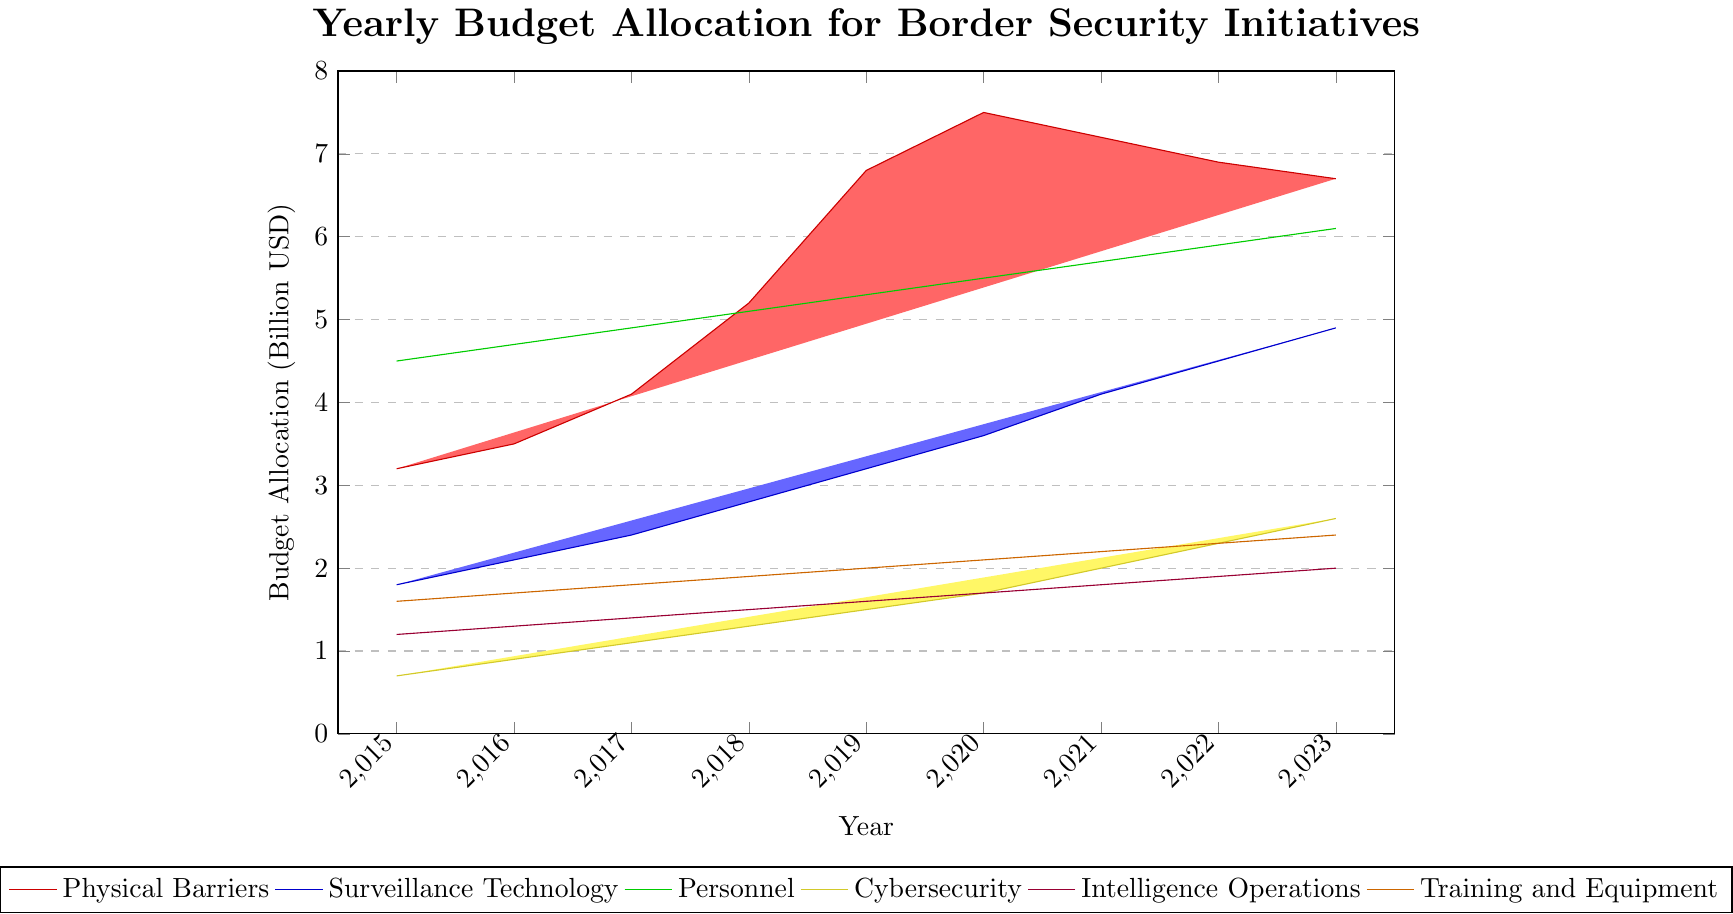What year had the highest budget allocation for Cybersecurity? The height of the yellow bars represents the budget allocation for Cybersecurity. The yellow bar is highest in 2023.
Answer: 2023 Compare the budget allocated to Physical Barriers in 2019 and 2021. Which year had a higher allocation? The height of the red bars representing Physical Barriers in 2019 and 2021 should be compared. The 2019 bar is slightly higher than the 2021 bar.
Answer: 2019 What is the total budget for Personnel in 2023 and 2022 combined? Add the height of the green bars for Personnel in 2023 and 2022. For 2023, it's 6.1 billion, and for 2022, it's 5.9 billion. Thus, 6.1 + 5.9 = 12 billion.
Answer: 12 billion USD Did the budget for Surveillance Technology increase every year from 2015 to 2023? Check the heights of the blue bars for Surveillance Technology for each year. Each subsequent year shows an increase from the previous year.
Answer: Yes In which year did the Training and Equipment budget surpass 2 billion USD? Observe the height of the orange bars for Training and Equipment. The bar surpasses 2 billion USD for the first time in 2023.
Answer: 2023 How does the budget for Intelligence Operations in 2020 compare to the budget in 2023? Compare the height of the purple bars for Intelligence Operations in 2020 and 2023. Both bars are equal in height, indicating that the budget remained the same at 1.7 billion USD.
Answer: Same Which budget allocation category shows the largest increase from 2016 to 2017? Calculate the differences in bar heights for each category between 2016 and 2017. Physical Barriers increased from 3.5 to 4.1 billion USD, an increase of 0.6 billion USD. Surveillance Technology increased from 2.1 to 2.4 billion USD, an increase of 0.3 billion USD. Personnel increased from 4.7 to 4.9 billion USD, an increase of 0.2 billion USD. Cybersecurity increased from 0.9 to 1.1 billion USD, an increase of 0.2 billion USD. Intelligence Operations increased from 1.3 to 1.4 billion USD, an increase of 0.1 billion USD. Training and Equipment increased from 1.7 to 1.8 billion USD, an increase of 0.1 billion USD. Therefore, Physical Barriers shows the largest increase.
Answer: Physical Barriers What's the cumulative budget allocation for Cybersecurity from 2015 to 2020? Sum the heights of the yellow bars for Cybersecurity from 2015 to 2020: 0.7 + 0.9 + 1.1 + 1.3 + 1.5 + 1.7 = 7.2 billion USD.
Answer: 7.2 billion USD What is the difference in the budget allocated to Training and Equipment between 2015 and 2023? Subtract the height of the orange bar for 2015 (1.6 billion USD) from the height of the orange bar for 2023 (2.4 billion USD). Thus, 2.4 - 1.6 = 0.8 billion USD.
Answer: 0.8 billion USD Which year had the smallest budget for Physical Barriers? Identify the smallest height of the red bars representing Physical Barriers. The smallest bar is in 2015.
Answer: 2015 